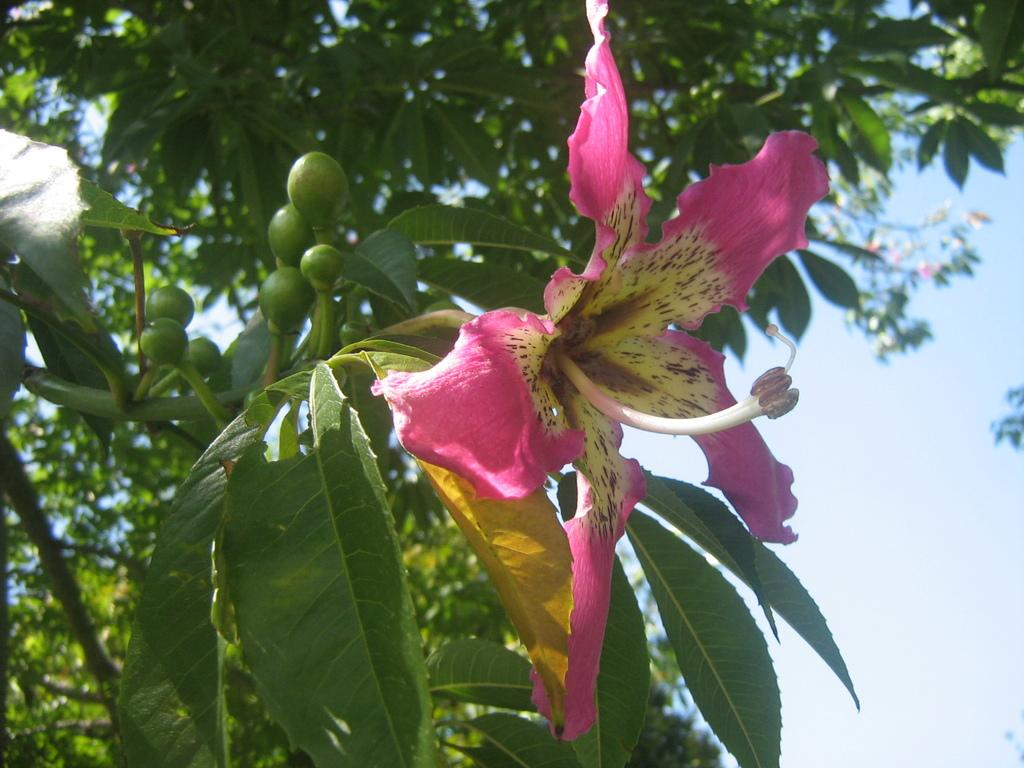What type of plant can be seen in the image? There is a tree in the image. What additional features can be observed on the tree? There are fruits on the tree in the image. What other elements are present in the image besides the tree? There are flowers and leaves in the image. What is the tax rate for the fruits on the tree in the image? There is no tax rate mentioned or implied in the image, as it is a visual representation of a tree with fruits. 